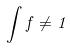Convert formula to latex. <formula><loc_0><loc_0><loc_500><loc_500>\int f \ne 1</formula> 